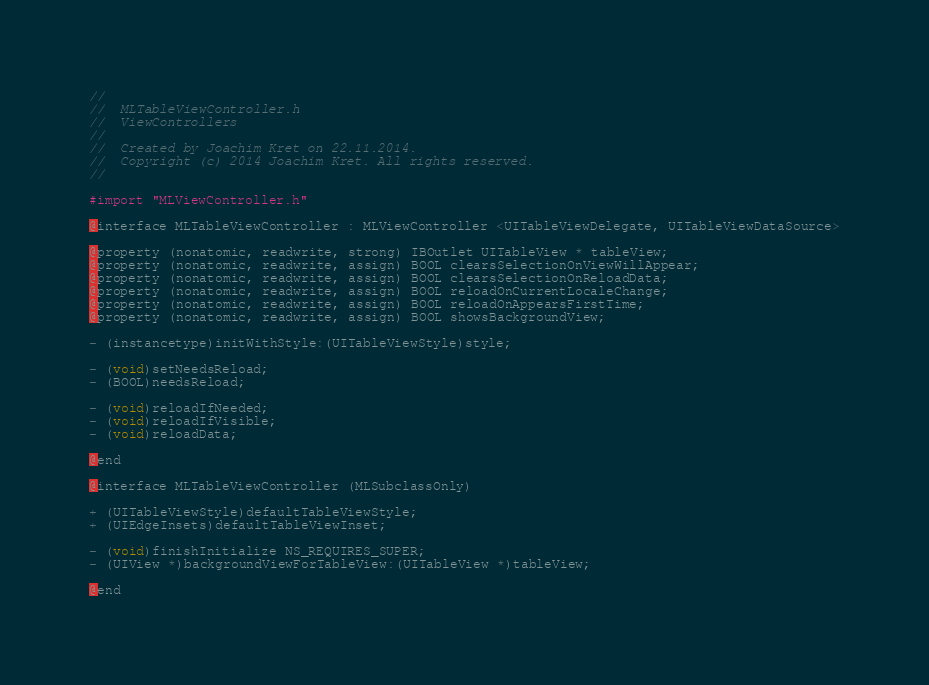Convert code to text. <code><loc_0><loc_0><loc_500><loc_500><_C_>//
//  MLTableViewController.h
//  ViewControllers
//
//  Created by Joachim Kret on 22.11.2014.
//  Copyright (c) 2014 Joachim Kret. All rights reserved.
//

#import "MLViewController.h"

@interface MLTableViewController : MLViewController <UITableViewDelegate, UITableViewDataSource>

@property (nonatomic, readwrite, strong) IBOutlet UITableView * tableView;
@property (nonatomic, readwrite, assign) BOOL clearsSelectionOnViewWillAppear;
@property (nonatomic, readwrite, assign) BOOL clearsSelectionOnReloadData;
@property (nonatomic, readwrite, assign) BOOL reloadOnCurrentLocaleChange;
@property (nonatomic, readwrite, assign) BOOL reloadOnAppearsFirstTime;
@property (nonatomic, readwrite, assign) BOOL showsBackgroundView;

- (instancetype)initWithStyle:(UITableViewStyle)style;

- (void)setNeedsReload;
- (BOOL)needsReload;

- (void)reloadIfNeeded;
- (void)reloadIfVisible;
- (void)reloadData;

@end

@interface MLTableViewController (MLSubclassOnly)

+ (UITableViewStyle)defaultTableViewStyle;
+ (UIEdgeInsets)defaultTableViewInset;

- (void)finishInitialize NS_REQUIRES_SUPER;
- (UIView *)backgroundViewForTableView:(UITableView *)tableView;

@end
</code> 